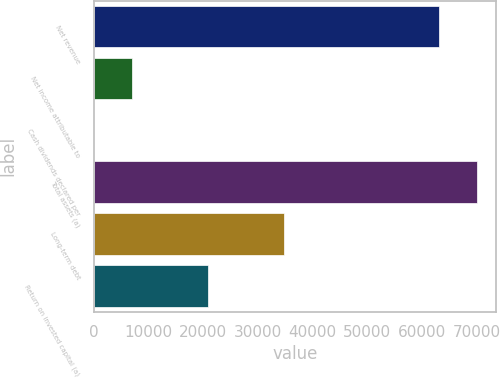Convert chart. <chart><loc_0><loc_0><loc_500><loc_500><bar_chart><fcel>Net revenue<fcel>Net income attributable to<fcel>Cash dividends declared per<fcel>Total assets (a)<fcel>Long-term debt<fcel>Return on invested capital (a)<nl><fcel>63056<fcel>6969.18<fcel>2.76<fcel>70022.4<fcel>34834.9<fcel>20902<nl></chart> 